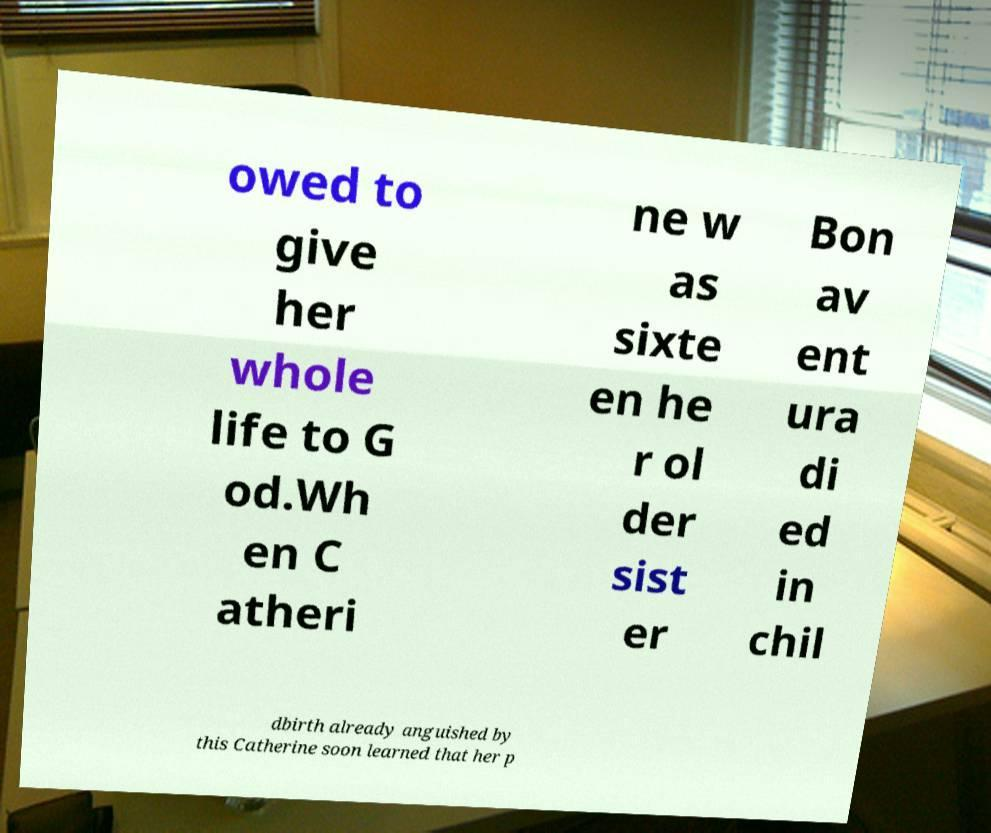Please read and relay the text visible in this image. What does it say? owed to give her whole life to G od.Wh en C atheri ne w as sixte en he r ol der sist er Bon av ent ura di ed in chil dbirth already anguished by this Catherine soon learned that her p 